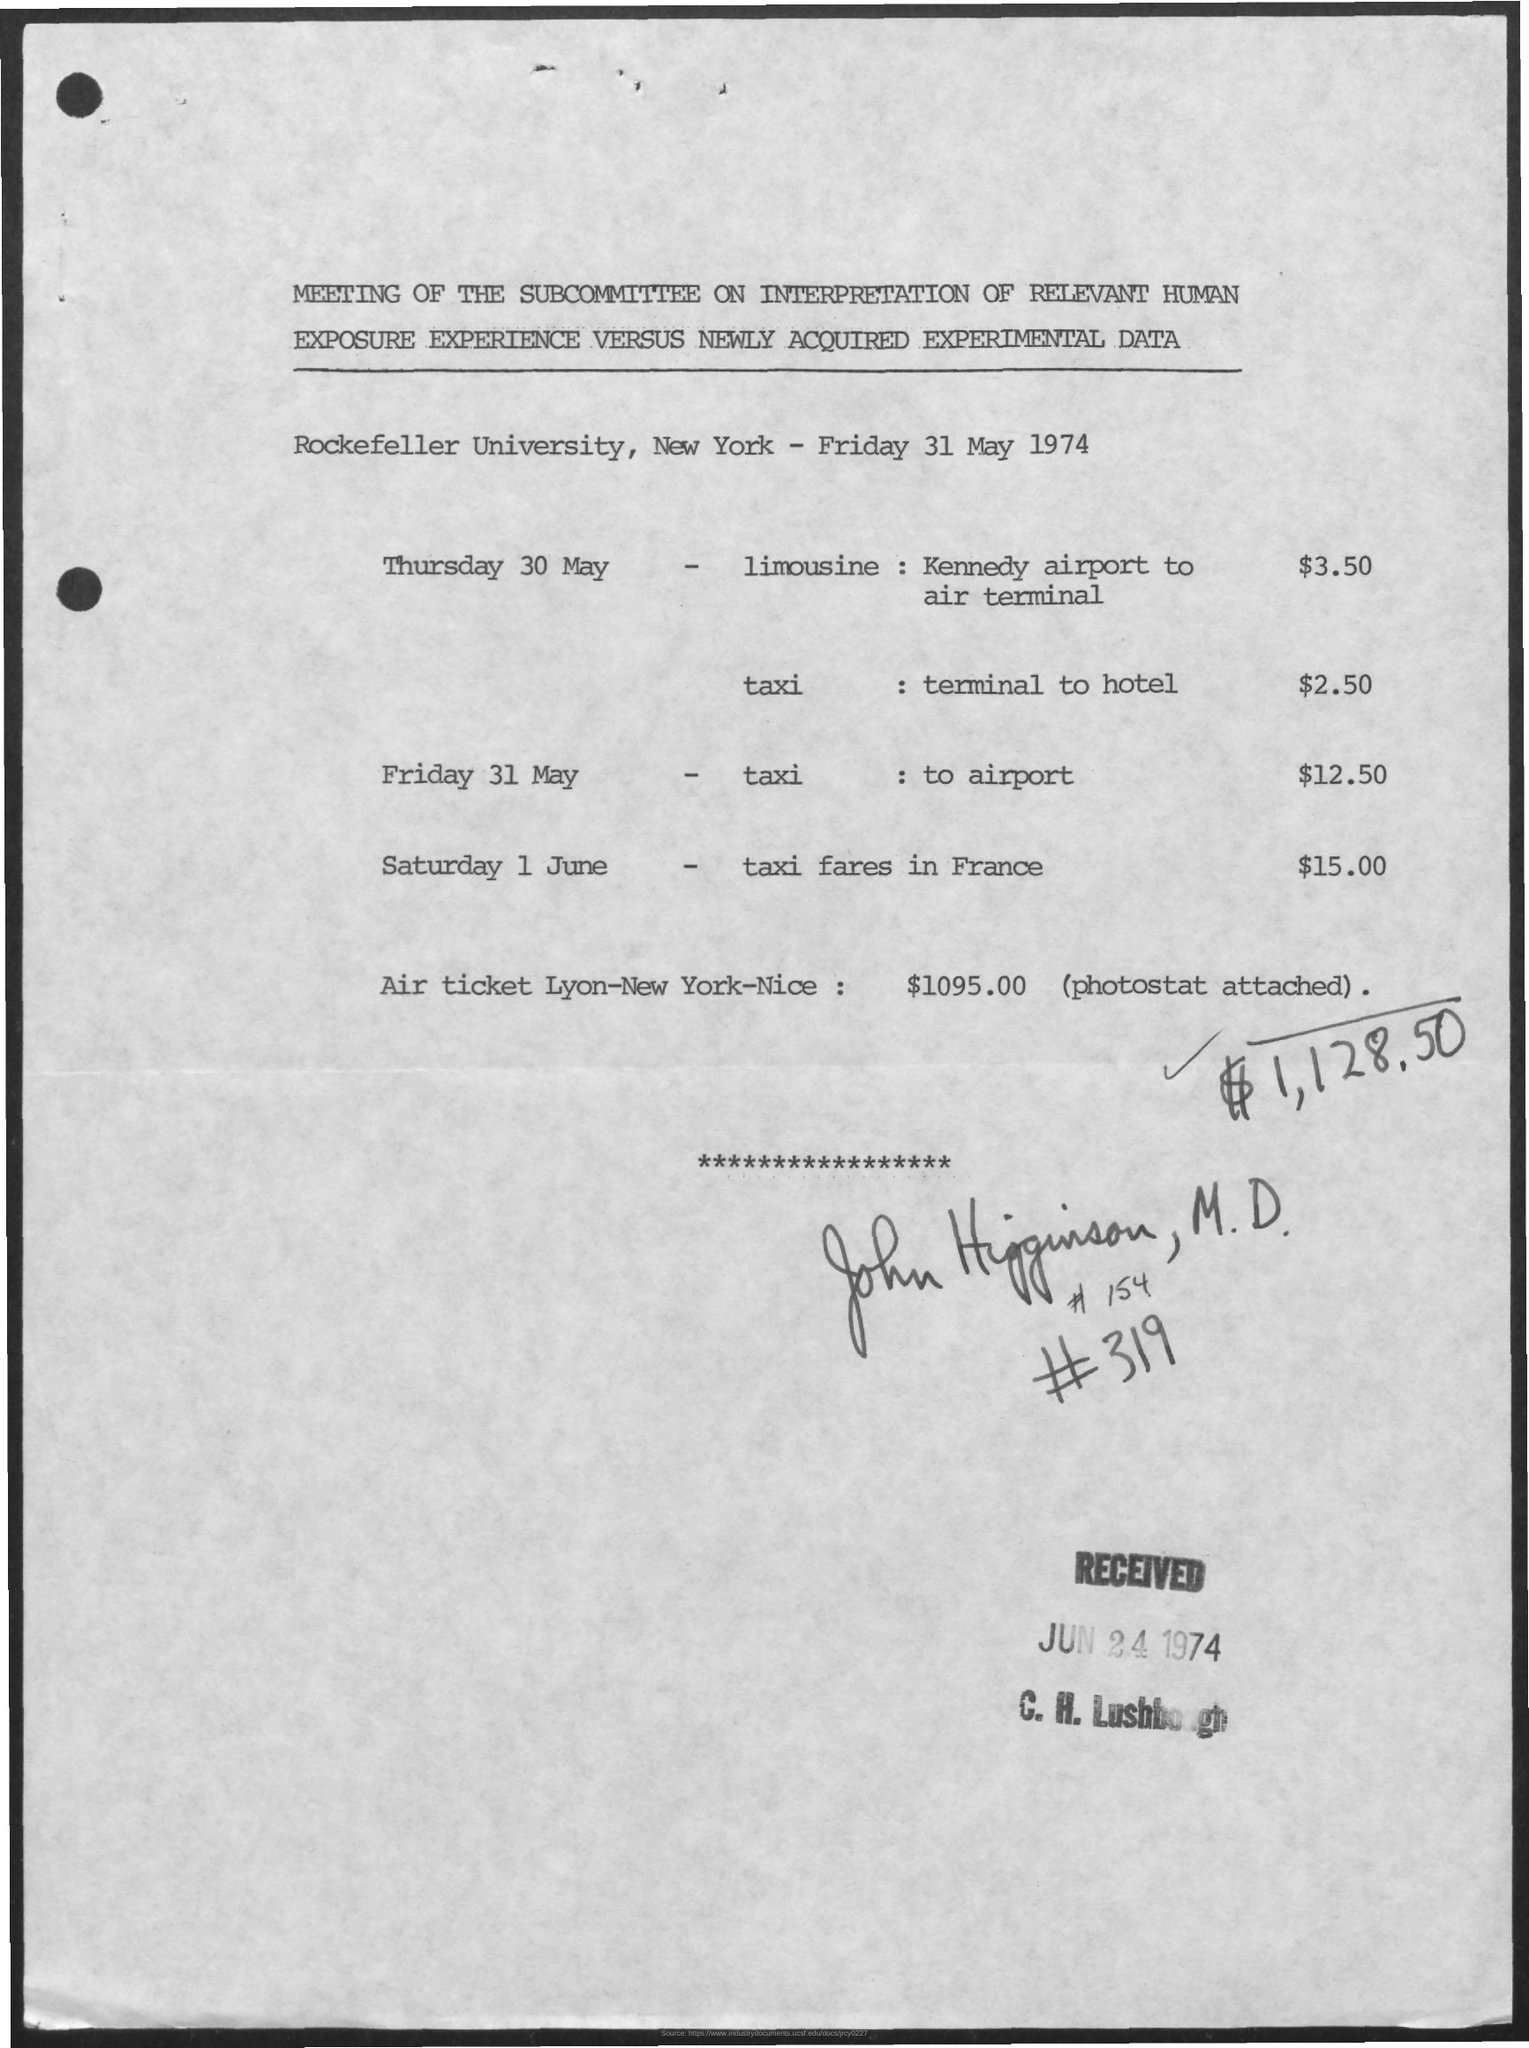Could you tell me more about the context of this meeting? Based on the document, it was a meeting of the Subcommittee on Interpretation of Relevant Human Exposure Experience versus Newly Acquired Experimental Data, held at Rockefeller University, New York, on Friday 31 May 1974. Specific details about the meeting's content or purpose are not provided in the image. 